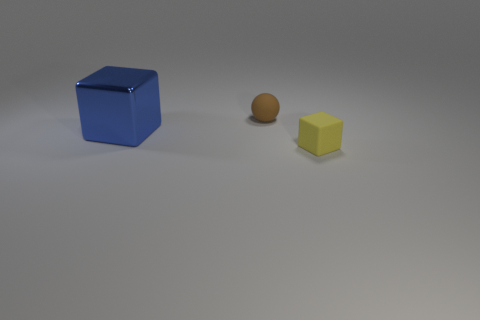Is there anything else that has the same material as the big object?
Provide a short and direct response. No. The small rubber object that is in front of the large shiny thing is what color?
Give a very brief answer. Yellow. Is the number of yellow rubber blocks on the left side of the tiny yellow block greater than the number of small red matte balls?
Ensure brevity in your answer.  No. Is the shape of the tiny rubber thing on the left side of the small yellow cube the same as  the blue metal object?
Give a very brief answer. No. How many brown things are spheres or cylinders?
Your answer should be compact. 1. Is the number of small cylinders greater than the number of balls?
Your response must be concise. No. The rubber block that is the same size as the ball is what color?
Ensure brevity in your answer.  Yellow. How many cubes are either large rubber objects or yellow objects?
Offer a very short reply. 1. Do the big metal object and the small thing that is left of the tiny yellow cube have the same shape?
Keep it short and to the point. No. How many yellow rubber things have the same size as the sphere?
Your response must be concise. 1. 